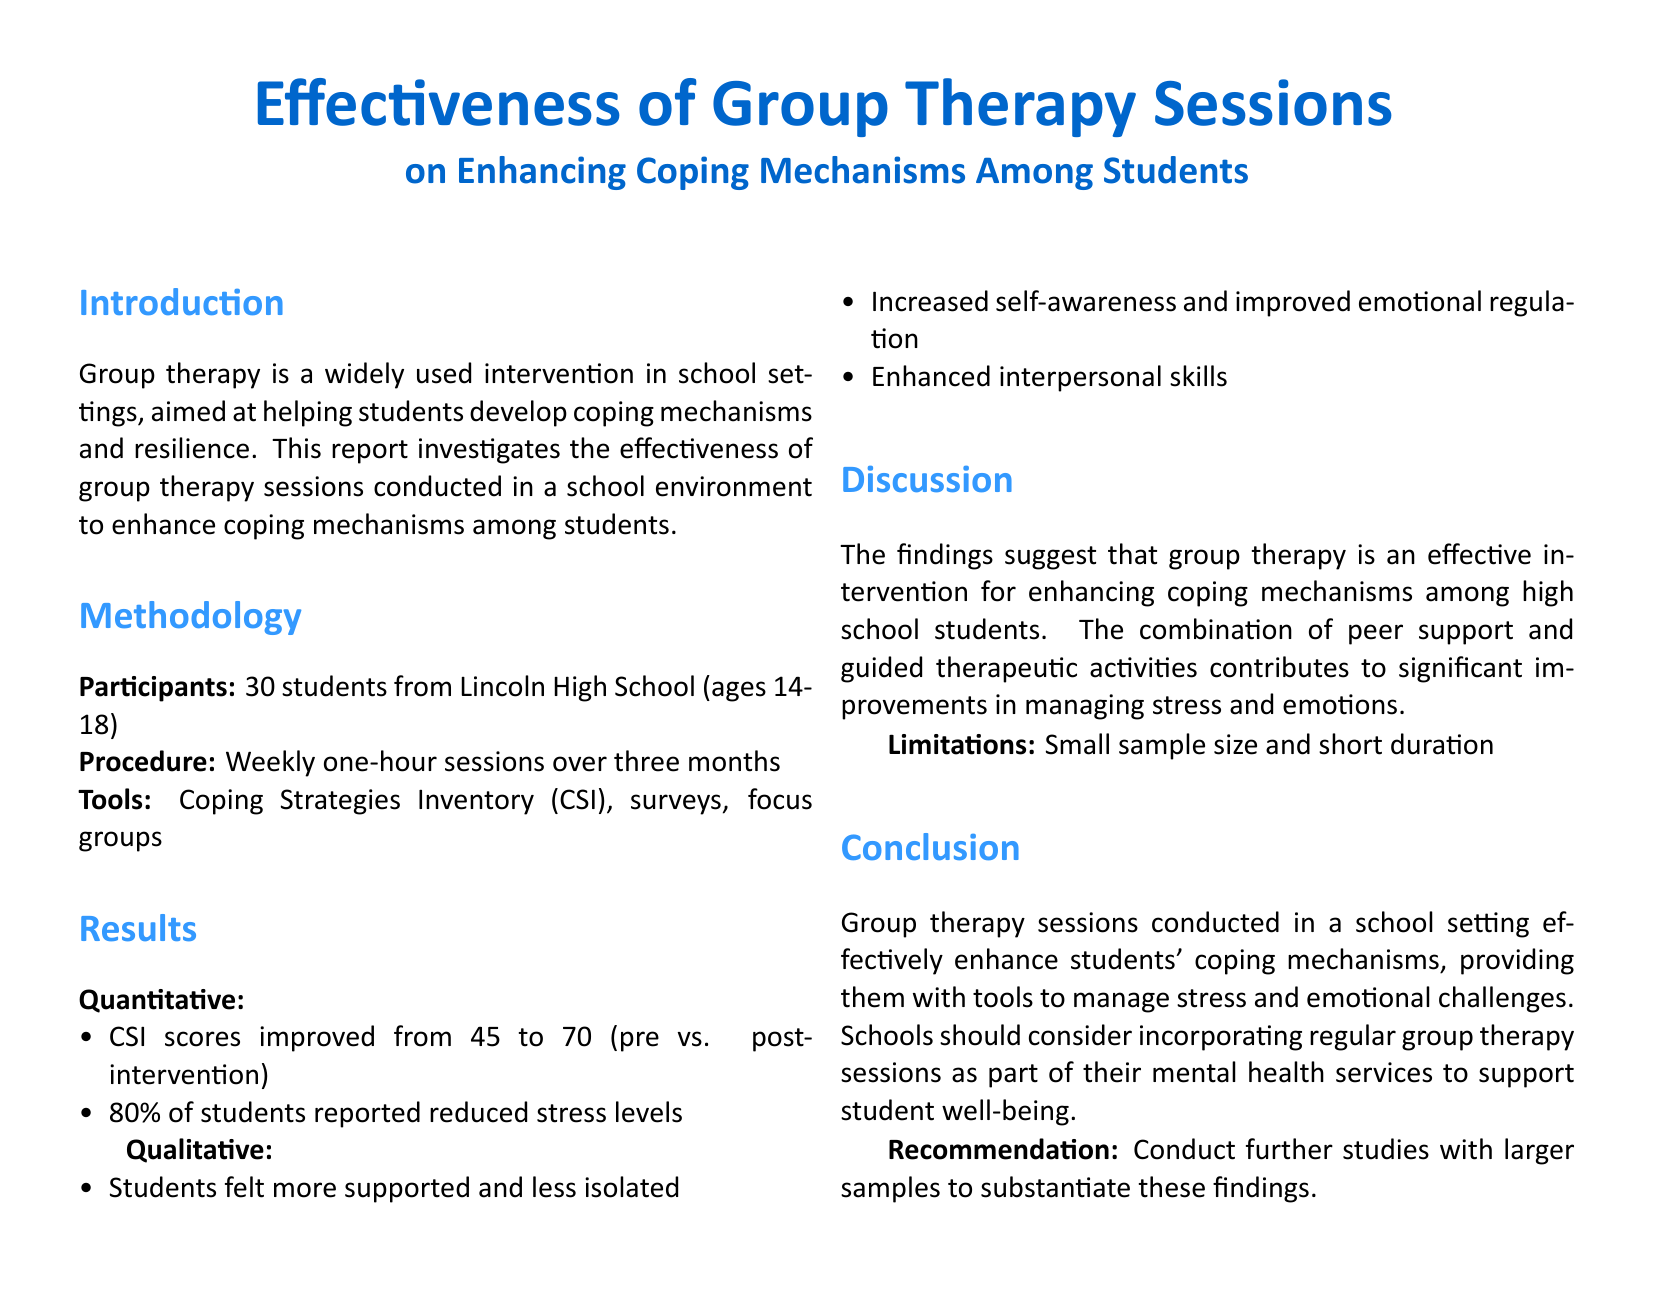What is the age range of participants? The age range of participants is specified in the methodology section of the document, which indicates ages 14-18.
Answer: 14-18 What was the improvement in CSI scores from pre to post-intervention? The document states that the CSI scores improved from 45 to 70.
Answer: 25 What percentage of students reported reduced stress levels? The results indicate that 80% of students reported reduced stress levels.
Answer: 80% What feelings did students express about support during the sessions? The qualitative results highlight that students felt more supported and less isolated.
Answer: Supported and less isolated What is identified as a limitation of the study? The discussion section mentions the small sample size and short duration as limitations of the study.
Answer: Small sample size and short duration What recommendation is made for future studies? The conclusion section suggests conducting further studies with larger samples to substantiate the findings.
Answer: Larger samples What type of therapy is the focus of the report? The report focuses on group therapy sessions conducted in a school environment.
Answer: Group therapy How long were the therapy sessions conducted? The methodology states that the sessions were conducted weekly for one hour over three months.
Answer: Three months What tool was used to measure coping strategies? The document lists the Coping Strategies Inventory (CSI) as a tool used in the study.
Answer: Coping Strategies Inventory (CSI) 